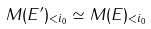Convert formula to latex. <formula><loc_0><loc_0><loc_500><loc_500>M ( E ^ { \prime } ) _ { < i _ { 0 } } \simeq M ( E ) _ { < i _ { 0 } }</formula> 